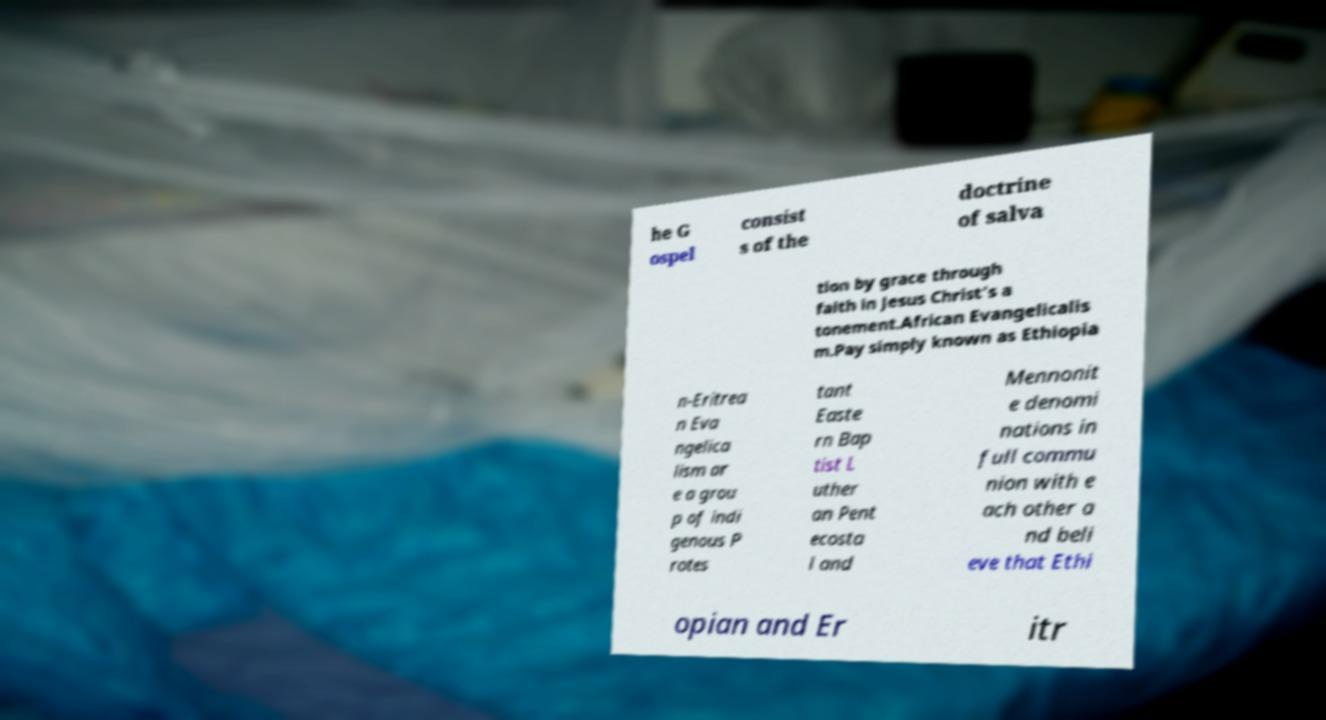For documentation purposes, I need the text within this image transcribed. Could you provide that? he G ospel consist s of the doctrine of salva tion by grace through faith in Jesus Christ's a tonement.African Evangelicalis m.Pay simply known as Ethiopia n-Eritrea n Eva ngelica lism ar e a grou p of indi genous P rotes tant Easte rn Bap tist L uther an Pent ecosta l and Mennonit e denomi nations in full commu nion with e ach other a nd beli eve that Ethi opian and Er itr 